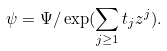Convert formula to latex. <formula><loc_0><loc_0><loc_500><loc_500>\psi = \Psi / \exp ( \sum _ { j \geq 1 } t _ { j } z ^ { j } ) .</formula> 